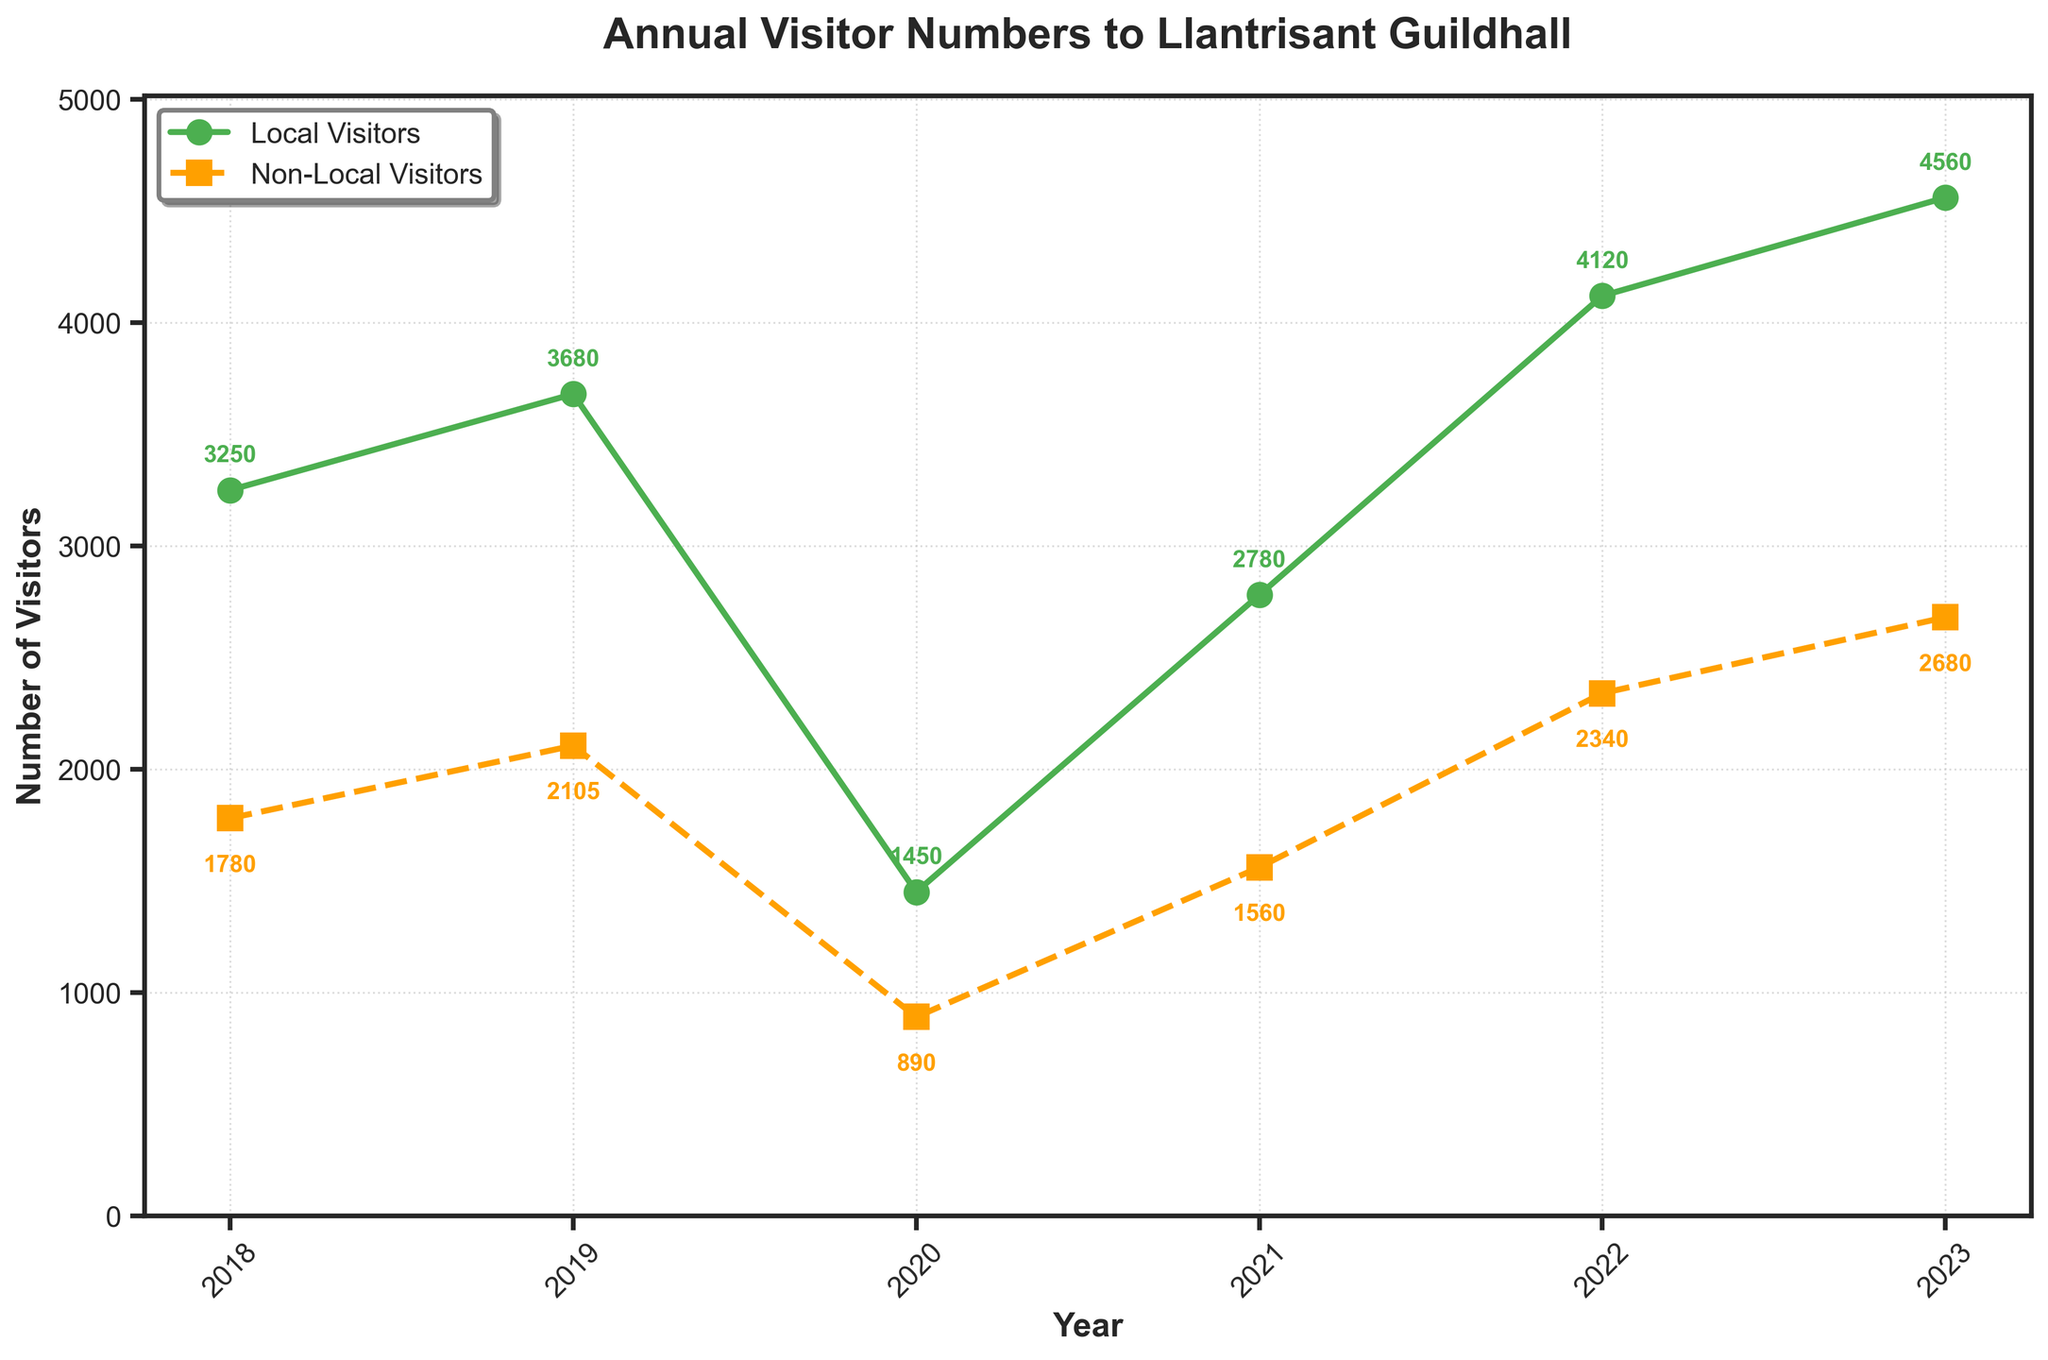What year had the highest number of non-local visitors? Observe the non-local visitors' line (dashed line). The highest data point on this line is in 2023.
Answer: 2023 How many more local visitors were there in 2022 compared to 2020? Look at the values for local visitors in 2022 (4120) and 2020 (1450). Subtract 1450 from 4120.
Answer: 2670 What's the average number of local visitors from 2018 to 2023? Add the local visitors' numbers from each year: 3250 + 3680 + 1450 + 2780 + 4120 + 4560 = 19840. Divide by the number of years (6).
Answer: 3306.67 Which group saw a decrease in visitor numbers from 2019 to 2020? Compare the values from 2019 to 2020 for both groups. Local visitors: 3680 to 1450 (decrease), Non-local visitors: 2105 to 890 (decrease). Both groups had a decrease, so mention the observation for both.
Answer: Both Local and Non-Local Which year saw the largest increase in local visitors compared to the previous year? Calculate the increase in local visitors each year: (2019-2018: 3680-3250=430), (2021-2020: 2780-1450=1330), (2022-2021: 4120-2780=1340), (2023-2022: 4560-4120=440). The largest increase is from 2021 to 2022 with an increase of 1340.
Answer: 2022 Are the numbers of local visitors in 2021 higher than the numbers of non-local visitors in 2019? Compare the values: Local visitors in 2021 (2780) and Non-local visitors in 2019 (2105). Since 2780 is greater than 2105, the answer is yes.
Answer: Yes What's the sum of non-local visitors across all the years? Add the non-local visitors' numbers from each year: 1780 + 2105 + 890 + 1560 + 2340 + 2680 = 11355.
Answer: 11355 What percentage of the total visitors in 2023 were local visitors? Find the total number of visitors in 2023: 4560 (local) + 2680 (non-local) = 7240. Calculate the percentage of local visitors: (4560 / 7240) * 100.
Answer: 63.03% Which year's non-local visitors show the slowest growth rate, and how can it be visualized? Calculate the growth rate for each year: (2019-2018: (2105-1780)/1780 = 18.27%), (2021-2020: (1560-890)/890=75.28%), (2022-2021: (2340-1560)/1560=50%), (2023-2022: (2680-2340)/2340=14.53%). The slowest growth rate occurs from 2022 to 2023.
Answer: 2023 